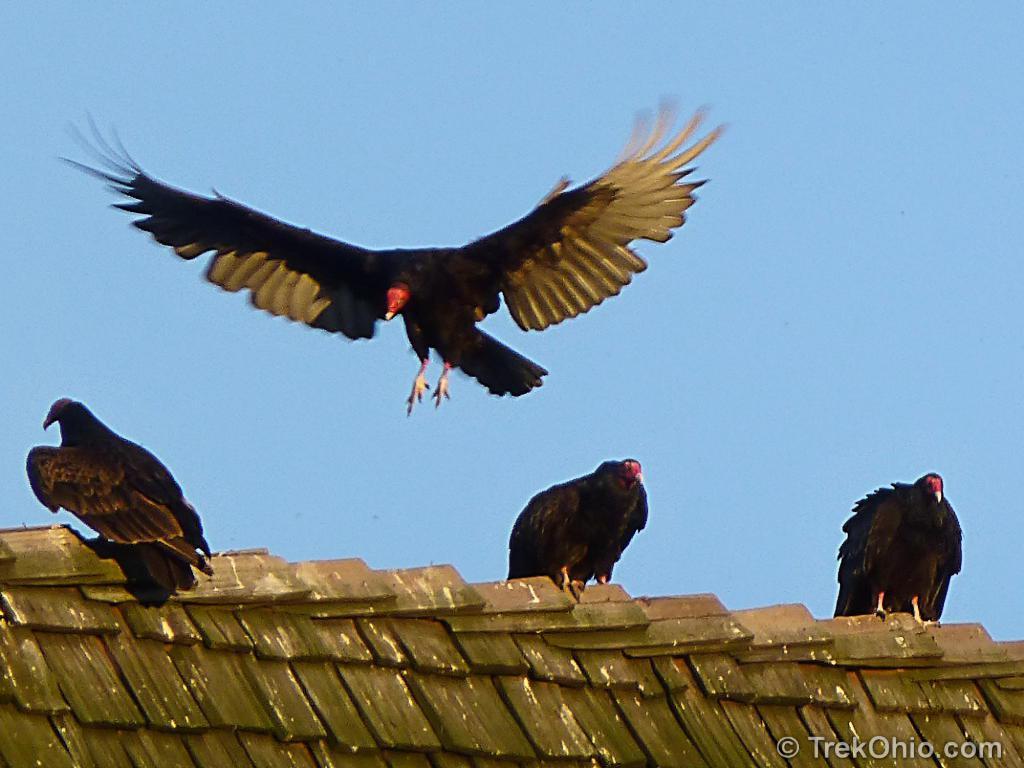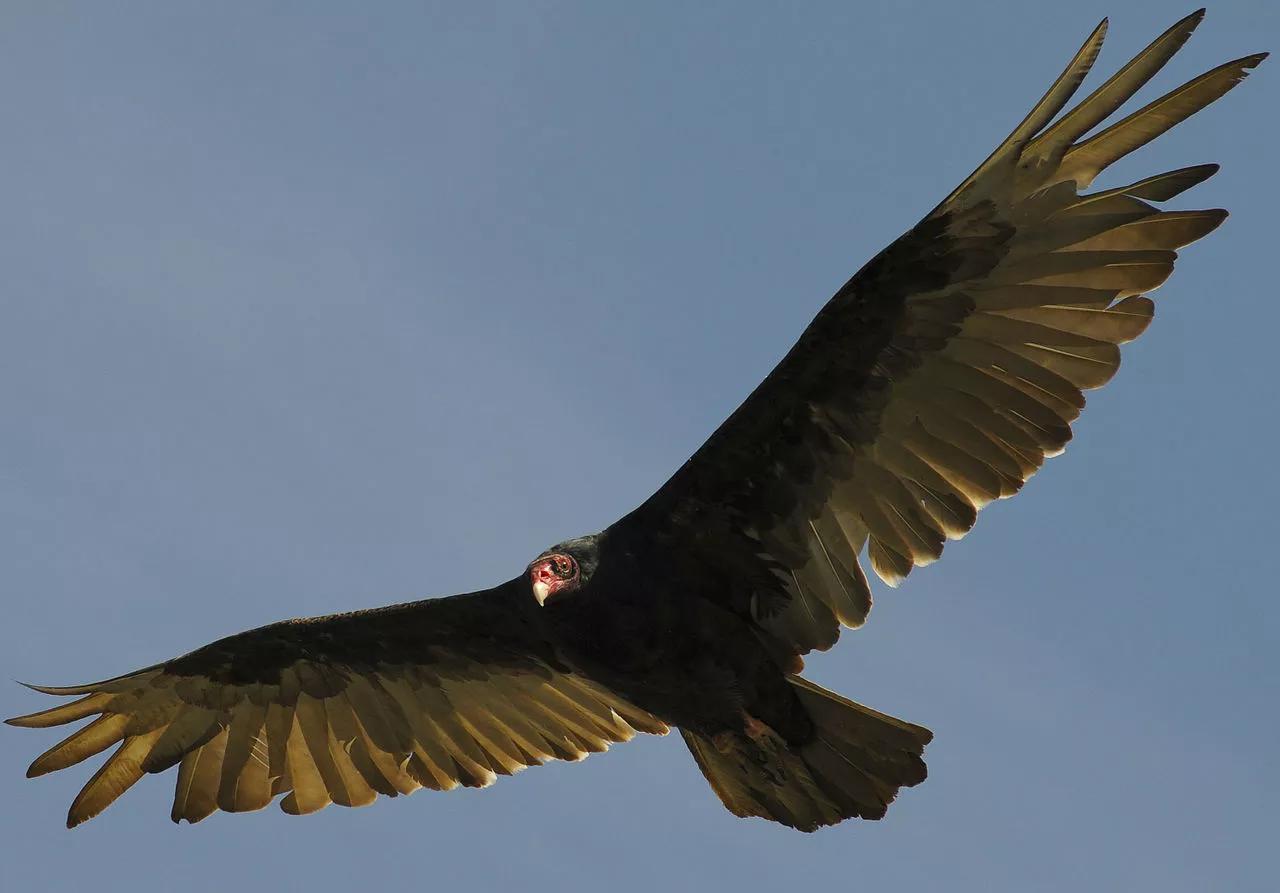The first image is the image on the left, the second image is the image on the right. For the images shown, is this caption "Two large birds have their wings extended, one in the air and one sitting." true? Answer yes or no. No. The first image is the image on the left, the second image is the image on the right. Examine the images to the left and right. Is the description "An image shows one vulture perched on something, with its wings spread horizontally." accurate? Answer yes or no. No. 